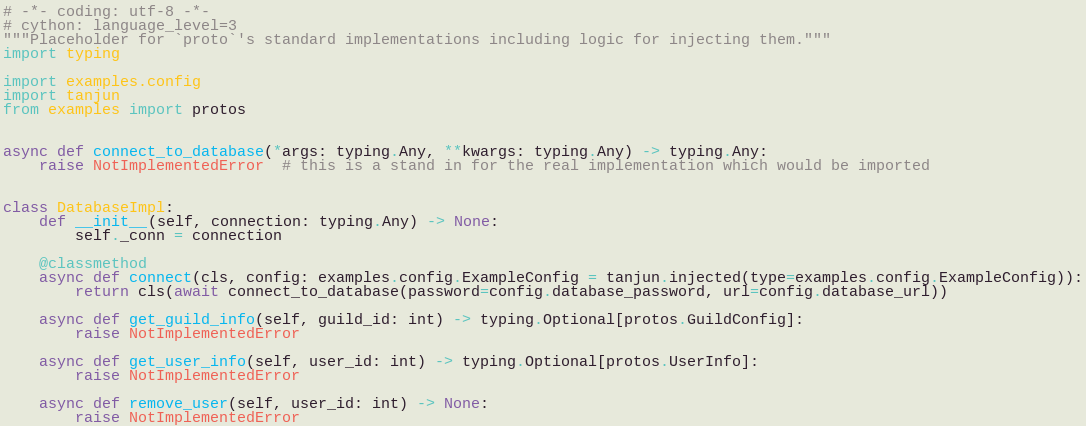Convert code to text. <code><loc_0><loc_0><loc_500><loc_500><_Python_># -*- coding: utf-8 -*-
# cython: language_level=3
"""Placeholder for `proto`'s standard implementations including logic for injecting them."""
import typing

import examples.config
import tanjun
from examples import protos


async def connect_to_database(*args: typing.Any, **kwargs: typing.Any) -> typing.Any:
    raise NotImplementedError  # this is a stand in for the real implementation which would be imported


class DatabaseImpl:
    def __init__(self, connection: typing.Any) -> None:
        self._conn = connection

    @classmethod
    async def connect(cls, config: examples.config.ExampleConfig = tanjun.injected(type=examples.config.ExampleConfig)):
        return cls(await connect_to_database(password=config.database_password, url=config.database_url))

    async def get_guild_info(self, guild_id: int) -> typing.Optional[protos.GuildConfig]:
        raise NotImplementedError

    async def get_user_info(self, user_id: int) -> typing.Optional[protos.UserInfo]:
        raise NotImplementedError

    async def remove_user(self, user_id: int) -> None:
        raise NotImplementedError
</code> 